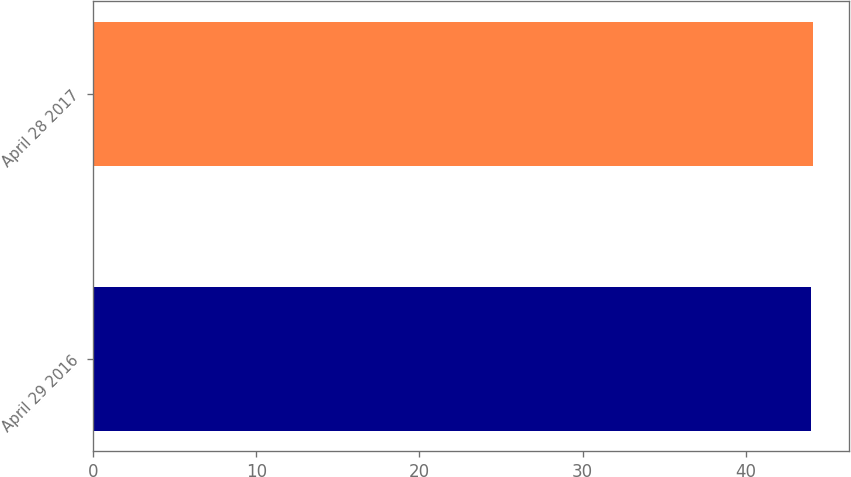Convert chart. <chart><loc_0><loc_0><loc_500><loc_500><bar_chart><fcel>April 29 2016<fcel>April 28 2017<nl><fcel>44<fcel>44.1<nl></chart> 